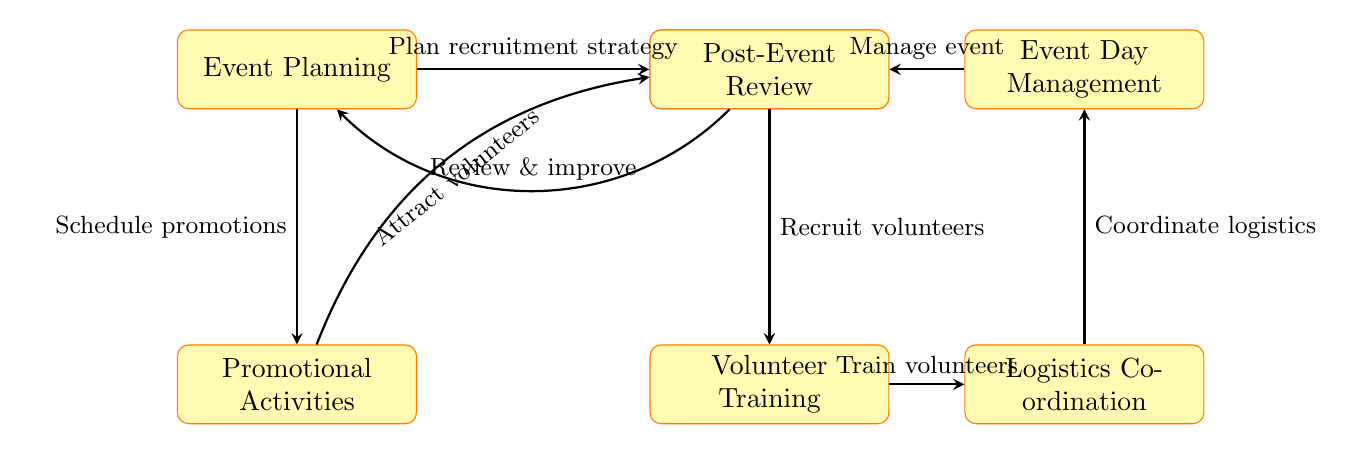What is the first process in the workflow? The first process in the workflow is "Event Planning," as indicated at the top-left of the diagram.
Answer: Event Planning How many main processes are represented in the diagram? Counting all the rectangular nodes, there are seven main processes depicted in the diagram.
Answer: 7 Which two processes are directly connected without any intermediate steps? The processes "Volunteer Recruitment" and "Volunteer Training" are directly connected; one follows immediately after the other in the sequence.
Answer: Volunteer Recruitment and Volunteer Training What action is associated with the arrow from "Event Day Management" to "Post-Event Review"? The action associated with that arrow is "Manage event," which signifies the management that leads to the review process.
Answer: Manage event What is the relationship between "Promotional Activities" and "Volunteer Recruitment"? "Promotional Activities" has a downward arrow towards "Volunteer Recruitment," indicating that promotions lead to or attract volunteers.
Answer: Attract volunteers Which process follows directly after "Logistics Coordination"? The process that follows directly after "Logistics Coordination" is "Event Day Management," as shown in the flow.
Answer: Event Day Management What feedback loop is indicated in the diagram? The feedback loop exists between "Post-Event Review" and "Event Planning," suggesting that the review leads back to planning for improvements.
Answer: Review & improve What process involves training volunteers? The process that involves training volunteers is "Volunteer Training," as indicated in the diagram.
Answer: Volunteer Training 